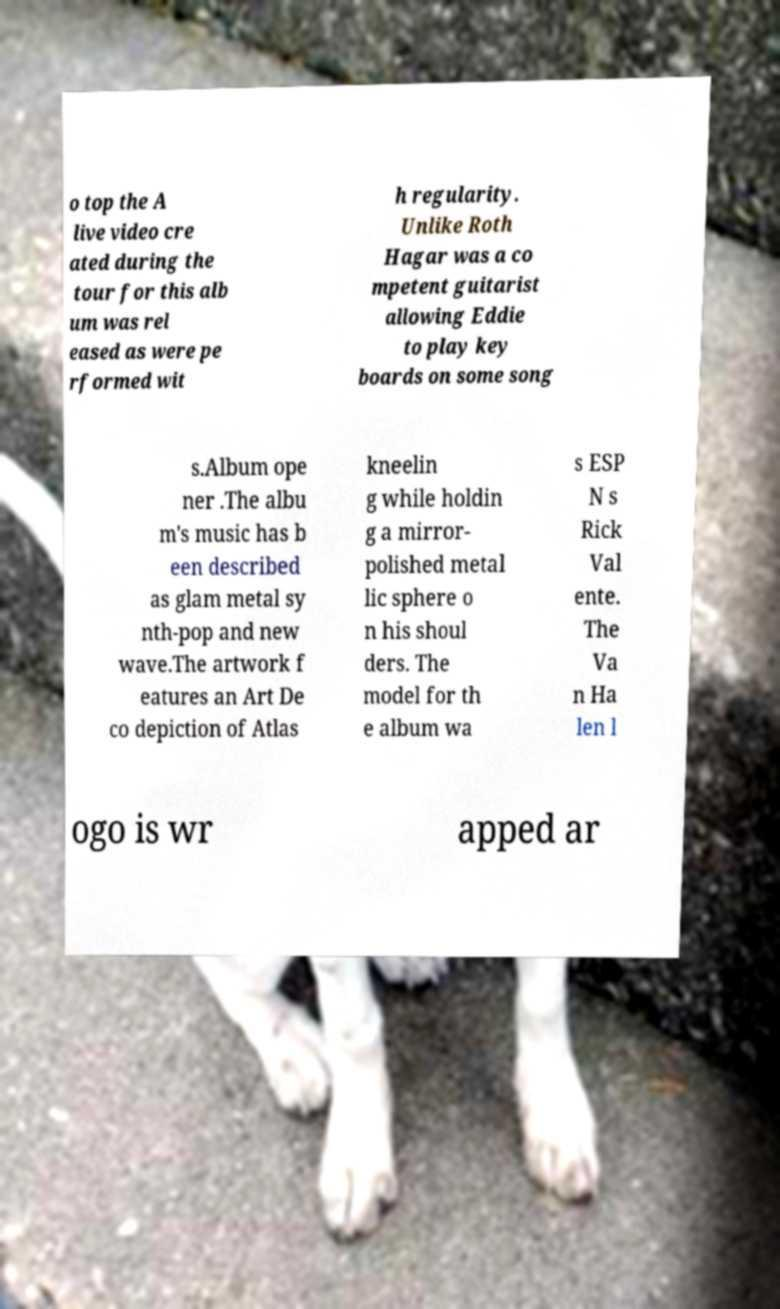Please identify and transcribe the text found in this image. o top the A live video cre ated during the tour for this alb um was rel eased as were pe rformed wit h regularity. Unlike Roth Hagar was a co mpetent guitarist allowing Eddie to play key boards on some song s.Album ope ner .The albu m's music has b een described as glam metal sy nth-pop and new wave.The artwork f eatures an Art De co depiction of Atlas kneelin g while holdin g a mirror- polished metal lic sphere o n his shoul ders. The model for th e album wa s ESP N s Rick Val ente. The Va n Ha len l ogo is wr apped ar 